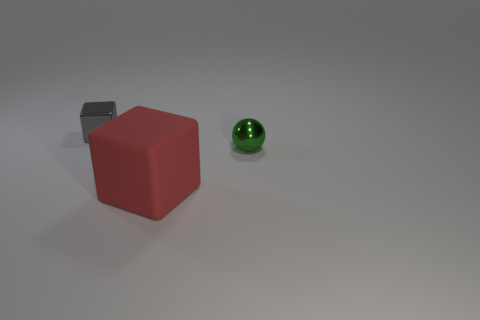Is there any other thing that has the same size as the red matte thing?
Your response must be concise. No. There is a small metal object that is on the right side of the cube that is right of the metal thing on the left side of the green sphere; what shape is it?
Your answer should be compact. Sphere. What number of big red objects have the same material as the green sphere?
Give a very brief answer. 0. There is a thing that is behind the green thing; how many gray cubes are in front of it?
Offer a very short reply. 0. What number of shiny spheres are there?
Offer a terse response. 1. Does the tiny gray thing have the same material as the small thing that is on the right side of the gray metallic thing?
Provide a short and direct response. Yes. The thing that is behind the large cube and to the left of the small green ball is made of what material?
Provide a short and direct response. Metal. What is the size of the metallic block?
Ensure brevity in your answer.  Small. How many other things are there of the same color as the small metallic sphere?
Your answer should be very brief. 0. There is a metallic object in front of the gray thing; is its size the same as the cube that is in front of the small gray metal thing?
Provide a short and direct response. No. 